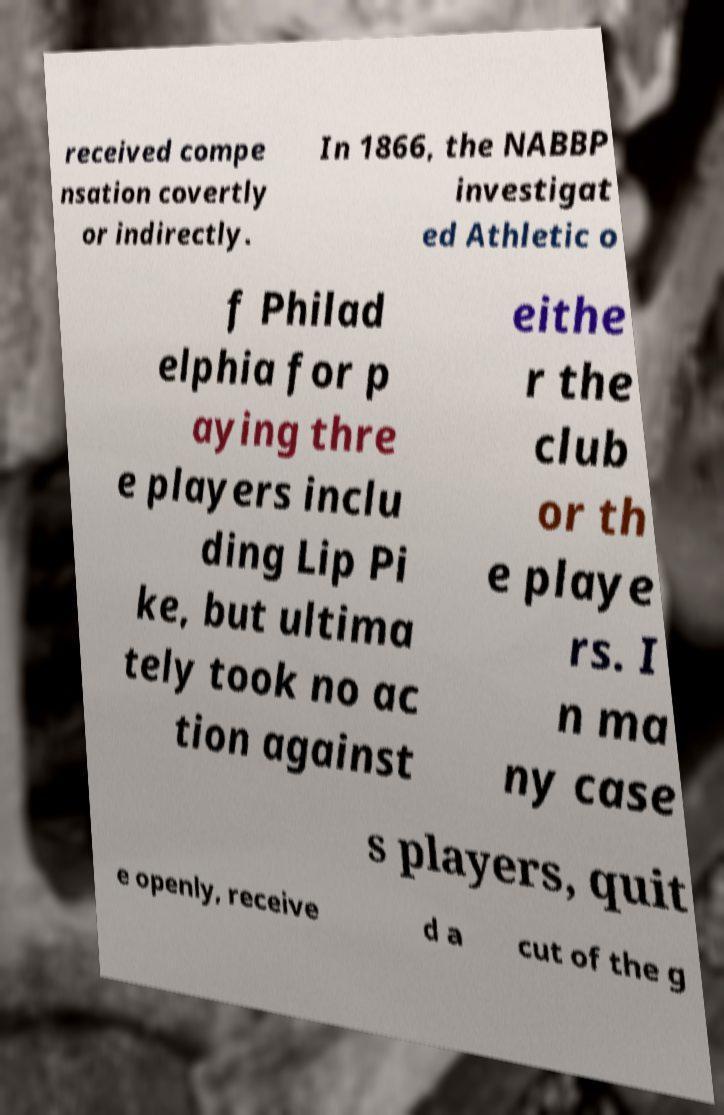Please identify and transcribe the text found in this image. received compe nsation covertly or indirectly. In 1866, the NABBP investigat ed Athletic o f Philad elphia for p aying thre e players inclu ding Lip Pi ke, but ultima tely took no ac tion against eithe r the club or th e playe rs. I n ma ny case s players, quit e openly, receive d a cut of the g 